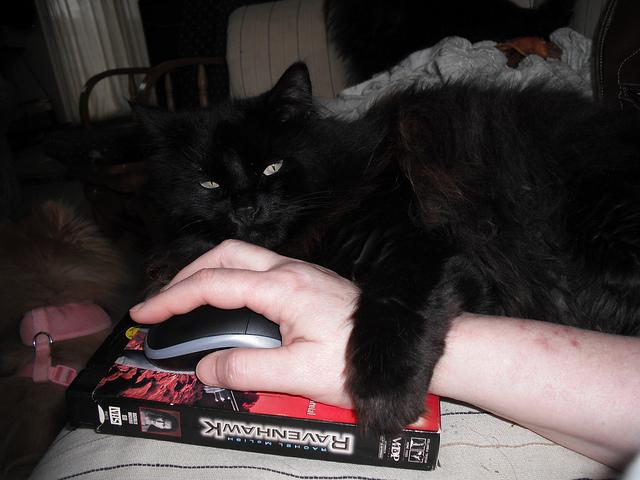Is the cat sleeping?
Give a very brief answer. No. What is the person holding?
Concise answer only. Mouse. What is the book being used as?
Short answer required. Mouse pad. 